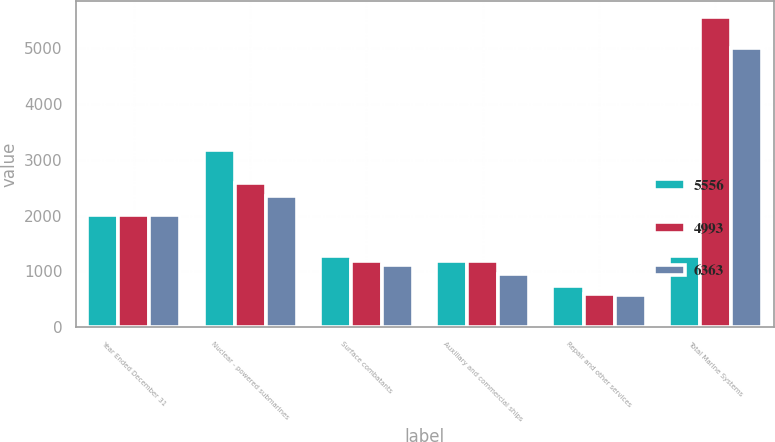Convert chart. <chart><loc_0><loc_0><loc_500><loc_500><stacked_bar_chart><ecel><fcel>Year Ended December 31<fcel>Nuclear - powered submarines<fcel>Surface combatants<fcel>Auxiliary and commercial ships<fcel>Repair and other services<fcel>Total Marine Systems<nl><fcel>5556<fcel>2009<fcel>3173<fcel>1278<fcel>1179<fcel>733<fcel>1278<nl><fcel>4993<fcel>2008<fcel>2579<fcel>1195<fcel>1192<fcel>590<fcel>5556<nl><fcel>6363<fcel>2007<fcel>2355<fcel>1112<fcel>953<fcel>573<fcel>4993<nl></chart> 